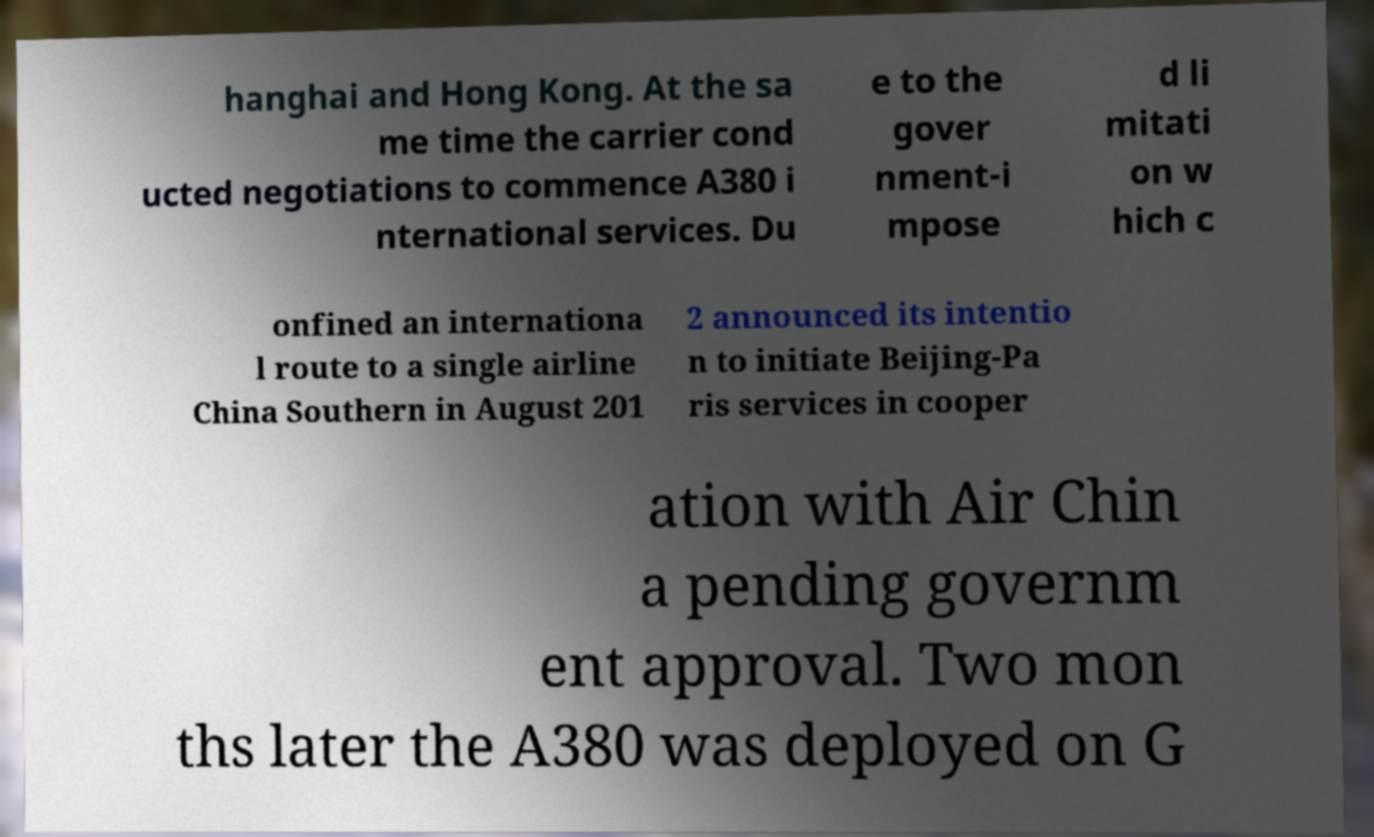I need the written content from this picture converted into text. Can you do that? hanghai and Hong Kong. At the sa me time the carrier cond ucted negotiations to commence A380 i nternational services. Du e to the gover nment-i mpose d li mitati on w hich c onfined an internationa l route to a single airline China Southern in August 201 2 announced its intentio n to initiate Beijing-Pa ris services in cooper ation with Air Chin a pending governm ent approval. Two mon ths later the A380 was deployed on G 